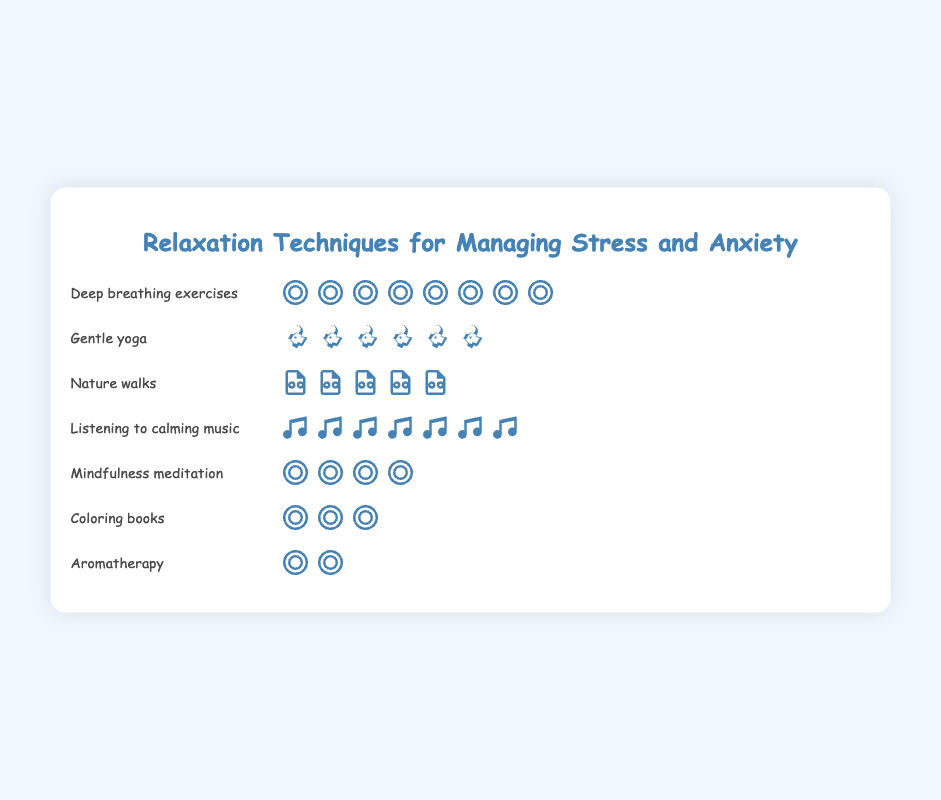What is the title of the figure? The title of the figure is displayed at the top and provides context for the data presented.
Answer: Relaxation Techniques for Managing Stress and Anxiety Which relaxation technique has the highest count? Count the number of icons for each technique and identify the one with the highest number. "Deep breathing exercises" has eight icons, which is the highest.
Answer: Deep breathing exercises How many techniques have a count of 5 or more? Count the number of techniques with 5 or more icons. "Deep breathing exercises" (8), "Gentle yoga" (6), "Listening to calming music" (7), and "Nature walks" (5).
Answer: 4 What is the combined total count for "Coloring books" and "Aromatherapy"? Add the counts for "Coloring books" (3) and "Aromatherapy" (2).
Answer: 5 Which relaxation technique has the fewest counts? Look for the technique with the least number of icons. "Aromatherapy" has the fewest with 2 icons.
Answer: Aromatherapy Which has more counts, "Mindfulness meditation" or "Gentle yoga"? Compare the number of icons for "Mindfulness meditation" (4) and "Gentle yoga" (6).
Answer: Gentle yoga What is the difference in counts between "Listening to calming music" and "Nature walks"? Subtract the count of "Nature walks" (5) from "Listening to calming music" (7).
Answer: 2 How many total techniques are displayed in the figure? Count the number of different relaxation techniques listed.
Answer: 7 